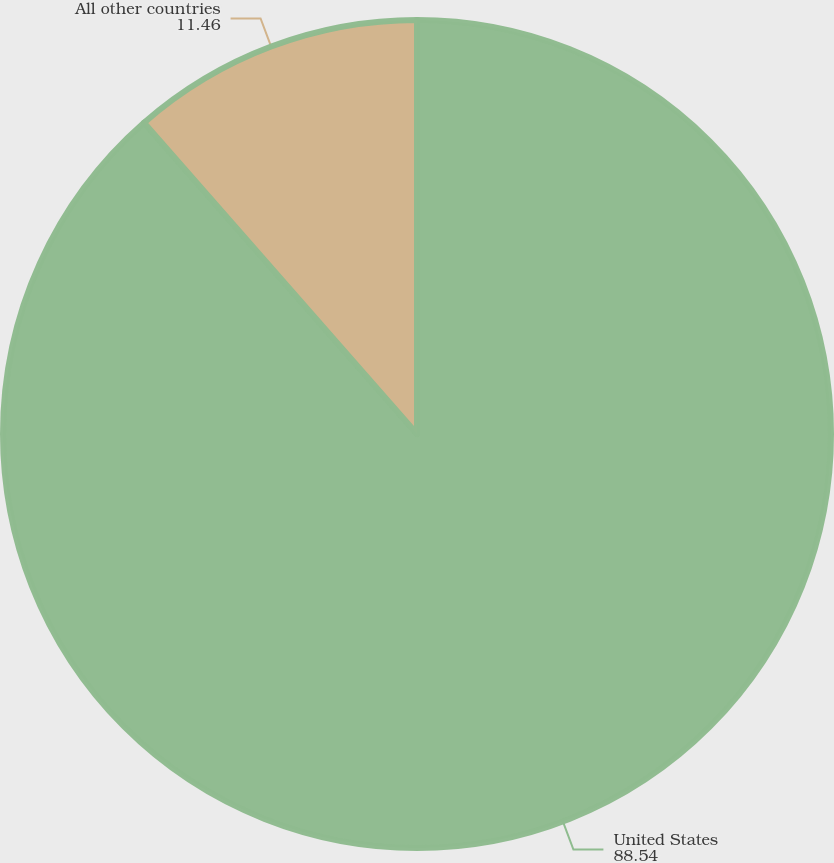<chart> <loc_0><loc_0><loc_500><loc_500><pie_chart><fcel>United States<fcel>All other countries<nl><fcel>88.54%<fcel>11.46%<nl></chart> 